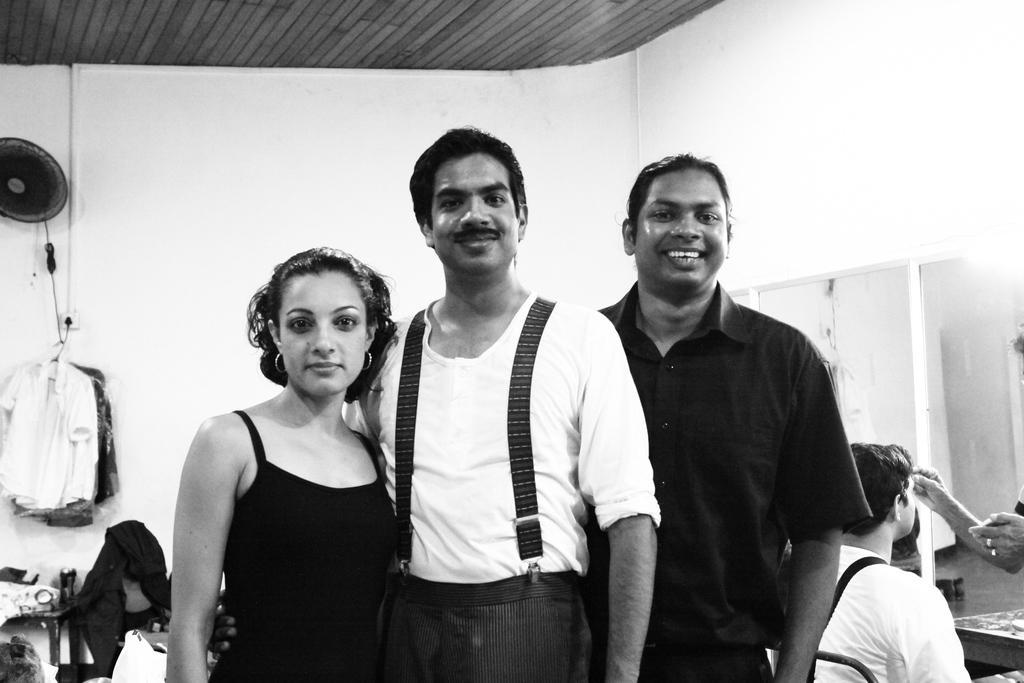Describe this image in one or two sentences. In this picture there is a man who is wearing a white t-shirt and trouser. Beside him we can see a woman is wearing black dress. On the right there is a man who is sitting on the chair and here we can see another man who is doing makeup to this person's face. On the right we can see mirrors on the wall. On the top we can see wooden roof. On the left there is a fan and clothes which are hanged on the wall. On the left we can see many clothes on the table. 